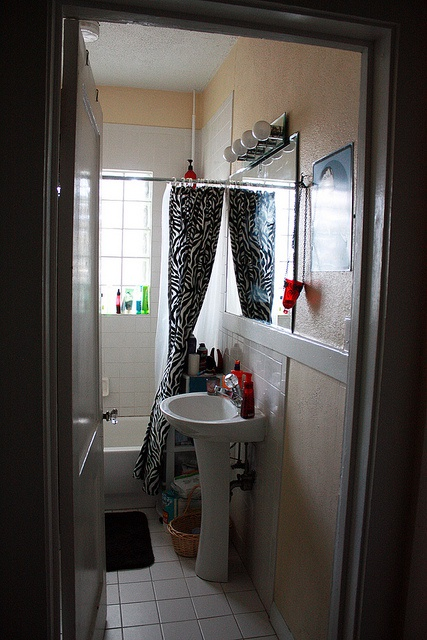Describe the objects in this image and their specific colors. I can see sink in black, gray, and darkgray tones and bottle in black, maroon, and gray tones in this image. 